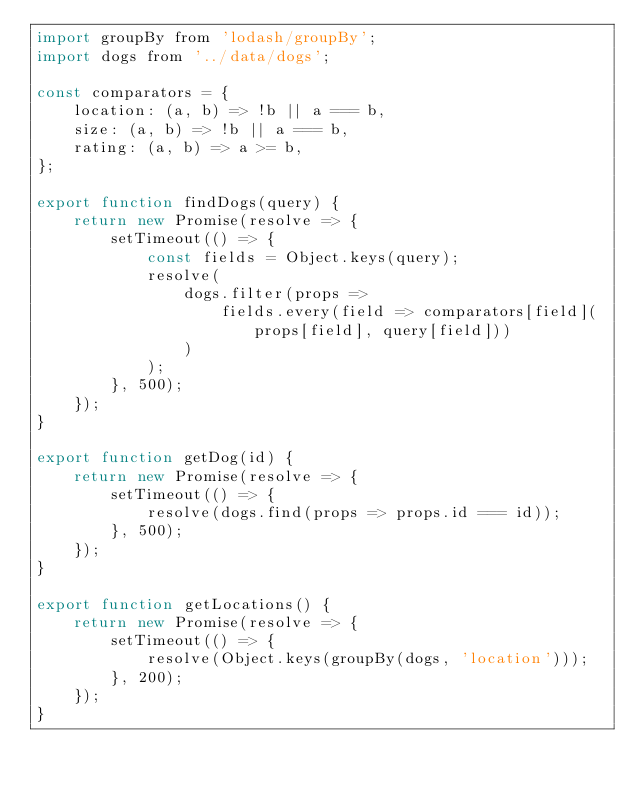<code> <loc_0><loc_0><loc_500><loc_500><_JavaScript_>import groupBy from 'lodash/groupBy';
import dogs from '../data/dogs';

const comparators = {
	location: (a, b) => !b || a === b,
	size: (a, b) => !b || a === b,
	rating: (a, b) => a >= b,
};

export function findDogs(query) {
	return new Promise(resolve => {
		setTimeout(() => {
			const fields = Object.keys(query);
			resolve(
				dogs.filter(props =>
					fields.every(field => comparators[field](props[field], query[field]))
				)
			);
		}, 500);
	});
}

export function getDog(id) {
	return new Promise(resolve => {
		setTimeout(() => {
			resolve(dogs.find(props => props.id === id));
		}, 500);
	});
}

export function getLocations() {
	return new Promise(resolve => {
		setTimeout(() => {
			resolve(Object.keys(groupBy(dogs, 'location')));
		}, 200);
	});
}
</code> 